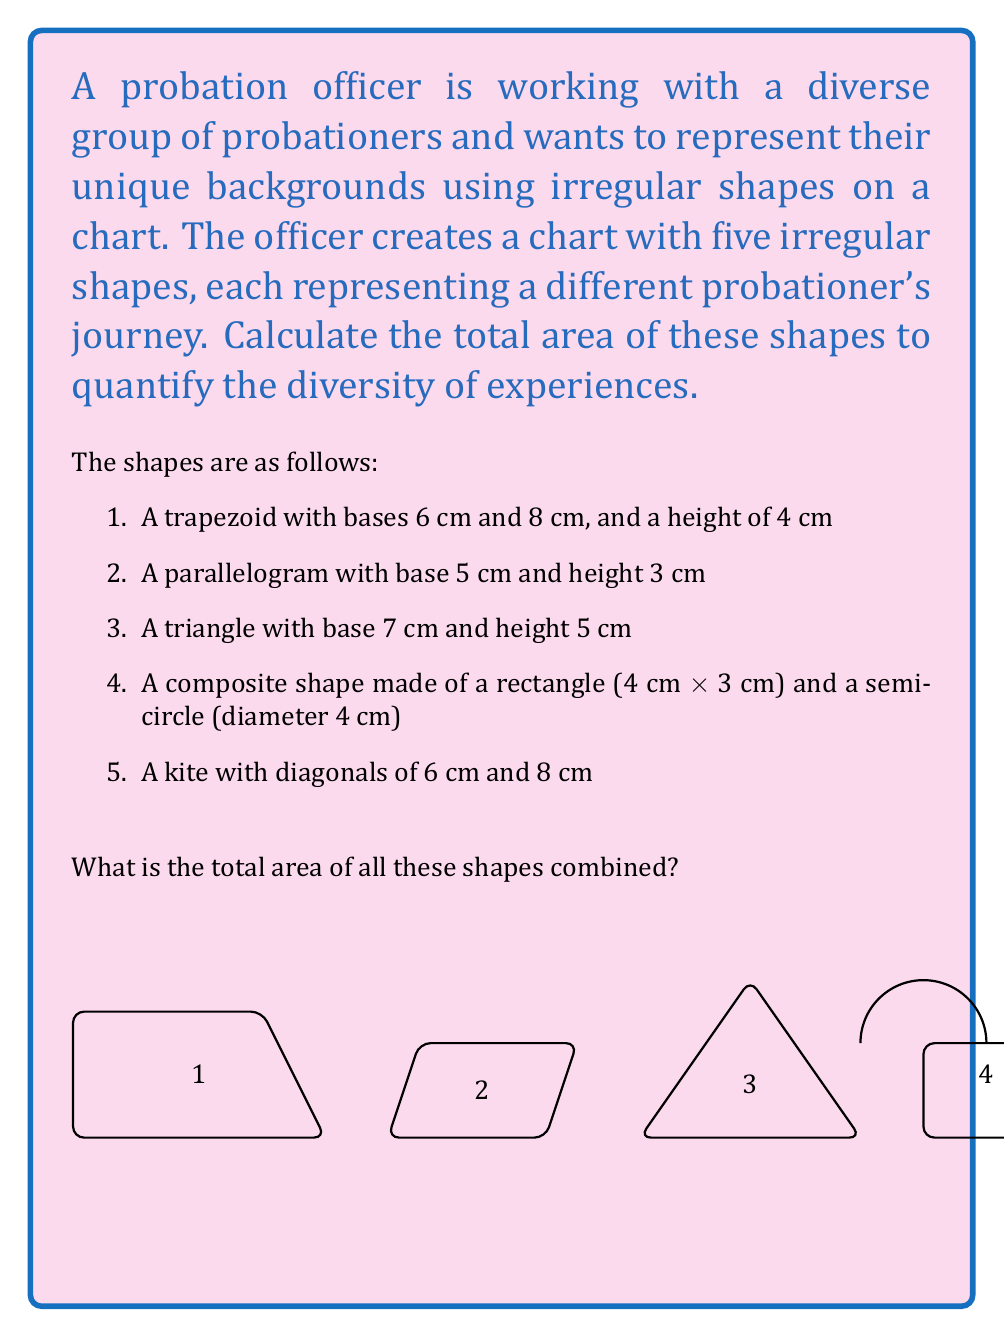Help me with this question. Let's calculate the area of each shape:

1. Trapezoid:
   Area = $\frac{1}{2}(a+b)h = \frac{1}{2}(6+8) \times 4 = 28$ cm²

2. Parallelogram:
   Area = $bh = 5 \times 3 = 15$ cm²

3. Triangle:
   Area = $\frac{1}{2}bh = \frac{1}{2} \times 7 \times 5 = 17.5$ cm²

4. Composite shape:
   Rectangle: $4 \times 3 = 12$ cm²
   Semi-circle: $\frac{1}{2} \times \pi r^2 = \frac{1}{2} \times \pi \times 2^2 = 2\pi$ cm²
   Total: $12 + 2\pi$ cm²

5. Kite:
   Area = $\frac{1}{2}d_1d_2 = \frac{1}{2} \times 6 \times 8 = 24$ cm²

Now, let's add all the areas:

$$\text{Total Area} = 28 + 15 + 17.5 + (12 + 2\pi) + 24$$
$$= 96.5 + 2\pi \text{ cm²}$$

To simplify, we can leave $\pi$ as it is or use an approximate value:
$$\approx 96.5 + 2(3.14159) \approx 102.78 \text{ cm²}$$
Answer: The total area is $96.5 + 2\pi$ cm², or approximately 102.78 cm². 